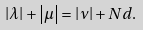<formula> <loc_0><loc_0><loc_500><loc_500>\left | \lambda \right | + \left | \mu \right | = \left | \nu \right | + N d .</formula> 